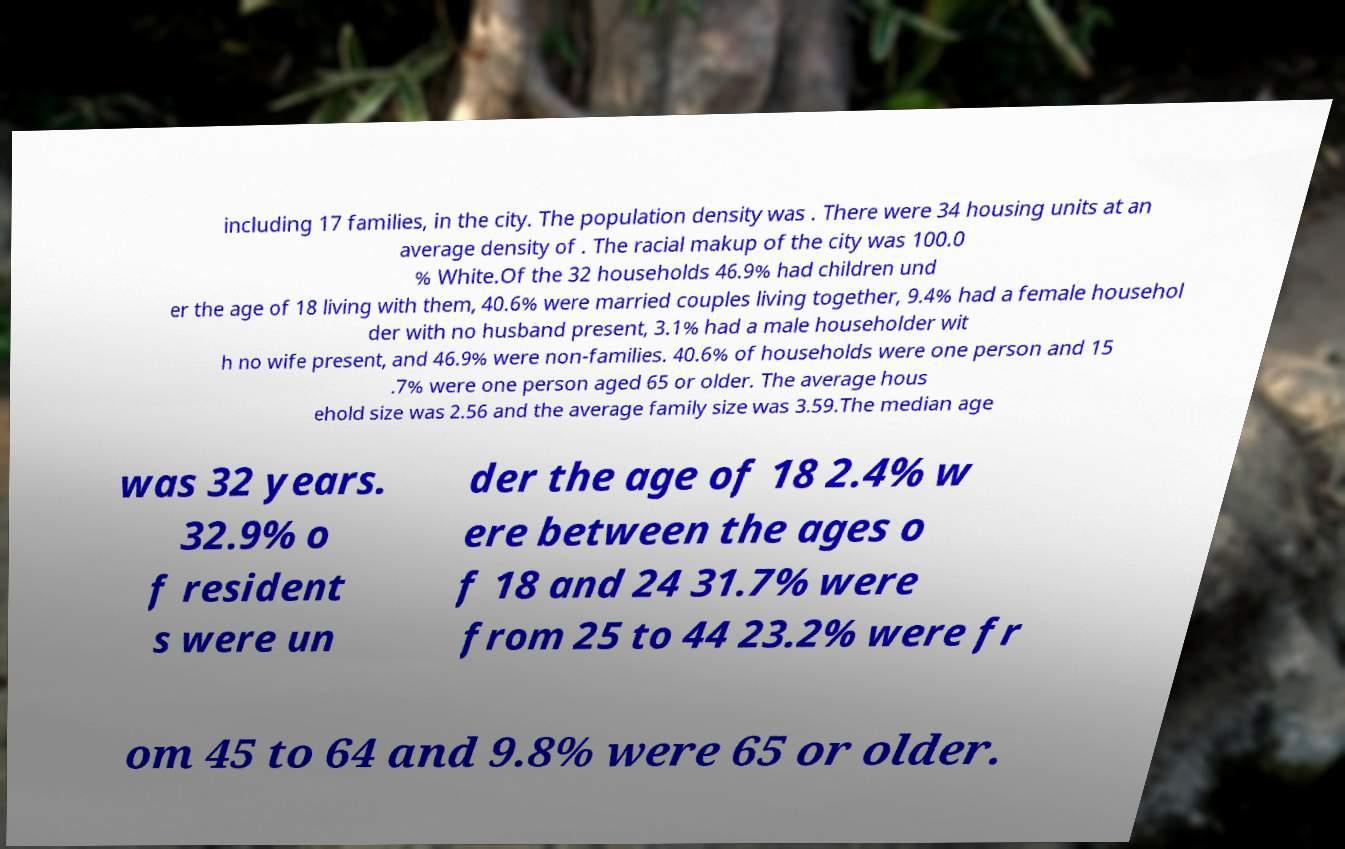Could you extract and type out the text from this image? including 17 families, in the city. The population density was . There were 34 housing units at an average density of . The racial makup of the city was 100.0 % White.Of the 32 households 46.9% had children und er the age of 18 living with them, 40.6% were married couples living together, 9.4% had a female househol der with no husband present, 3.1% had a male householder wit h no wife present, and 46.9% were non-families. 40.6% of households were one person and 15 .7% were one person aged 65 or older. The average hous ehold size was 2.56 and the average family size was 3.59.The median age was 32 years. 32.9% o f resident s were un der the age of 18 2.4% w ere between the ages o f 18 and 24 31.7% were from 25 to 44 23.2% were fr om 45 to 64 and 9.8% were 65 or older. 